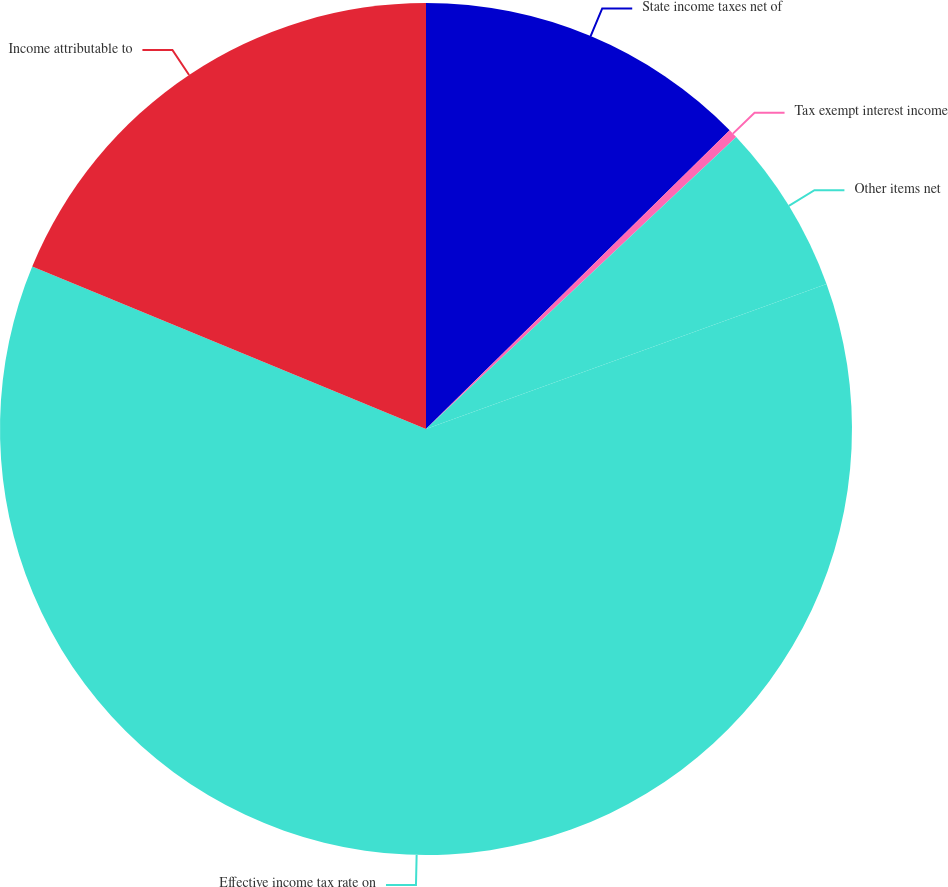Convert chart to OTSL. <chart><loc_0><loc_0><loc_500><loc_500><pie_chart><fcel>State income taxes net of<fcel>Tax exempt interest income<fcel>Other items net<fcel>Effective income tax rate on<fcel>Income attributable to<nl><fcel>12.63%<fcel>0.35%<fcel>6.49%<fcel>61.76%<fcel>18.77%<nl></chart> 